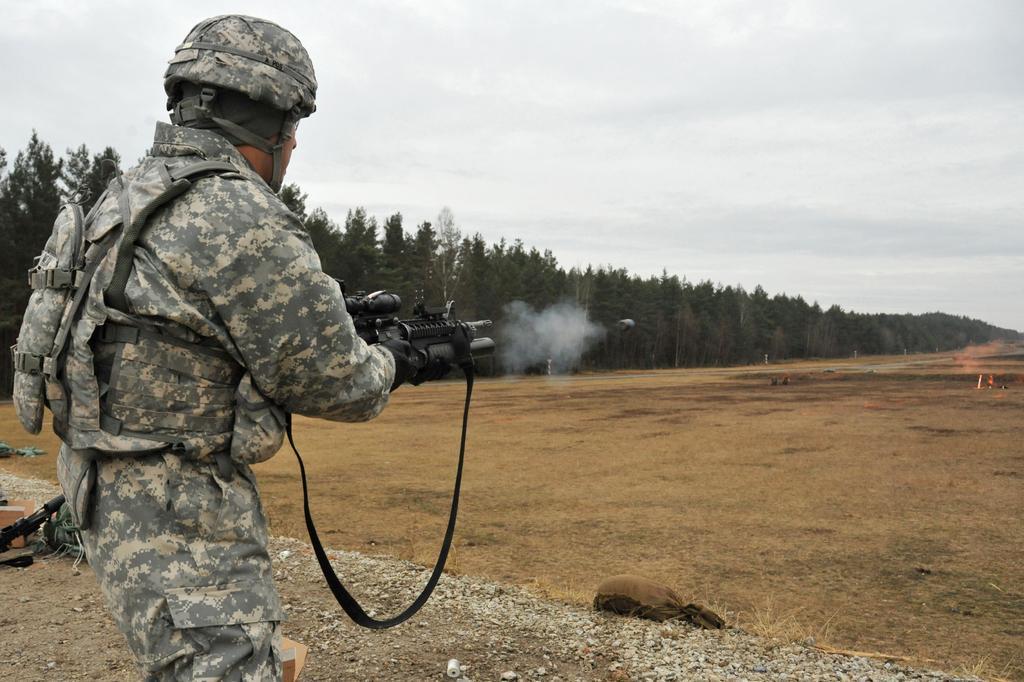How would you summarize this image in a sentence or two? In the foreground of the picture there is a soldier firing gun. In the center of the picture there are trees. On the right it is field. In the foreground there are stones, bags and guns. Sky is cloudy. 